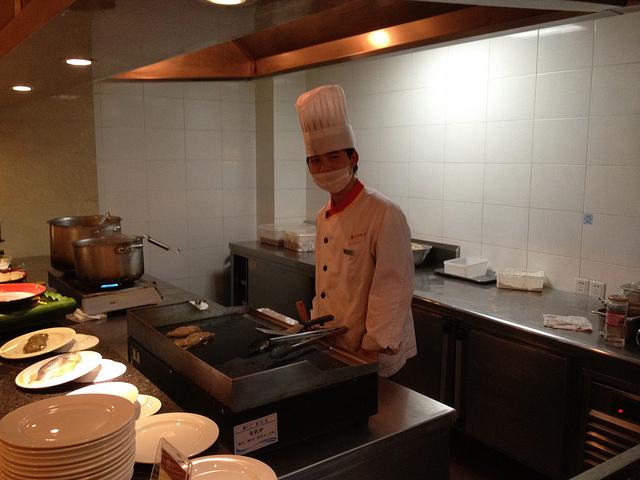Is the person wearing a mask?
Concise answer only. Yes. Is this a kitchen?
Write a very short answer. Yes. What color is the tile wall?
Quick response, please. White. 